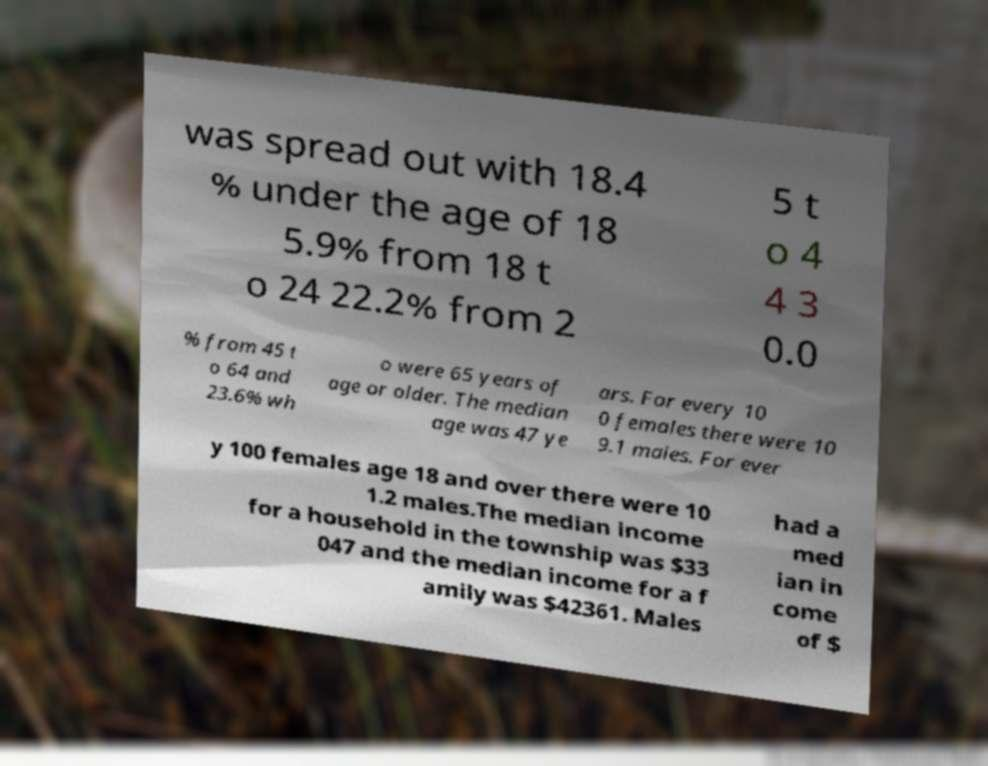Please read and relay the text visible in this image. What does it say? was spread out with 18.4 % under the age of 18 5.9% from 18 t o 24 22.2% from 2 5 t o 4 4 3 0.0 % from 45 t o 64 and 23.6% wh o were 65 years of age or older. The median age was 47 ye ars. For every 10 0 females there were 10 9.1 males. For ever y 100 females age 18 and over there were 10 1.2 males.The median income for a household in the township was $33 047 and the median income for a f amily was $42361. Males had a med ian in come of $ 